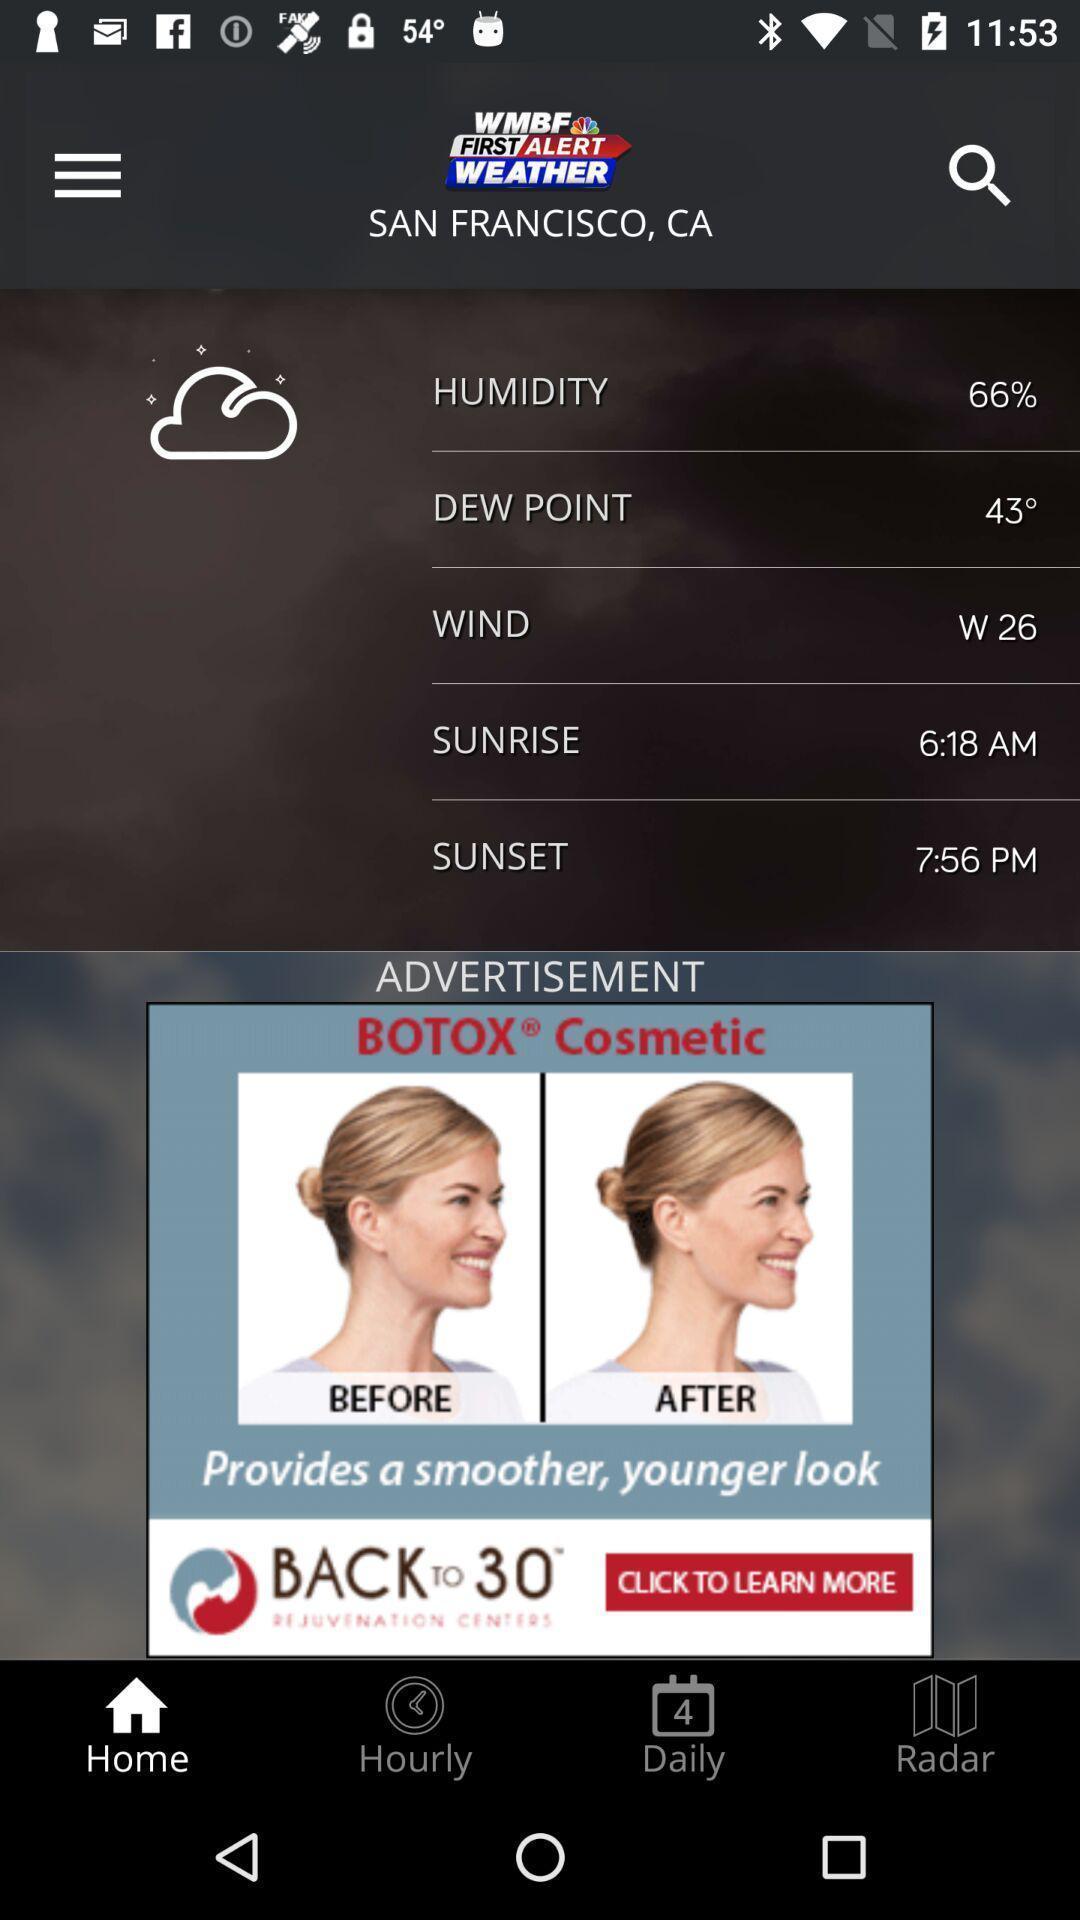Provide a detailed account of this screenshot. Weather information showing in this page. 